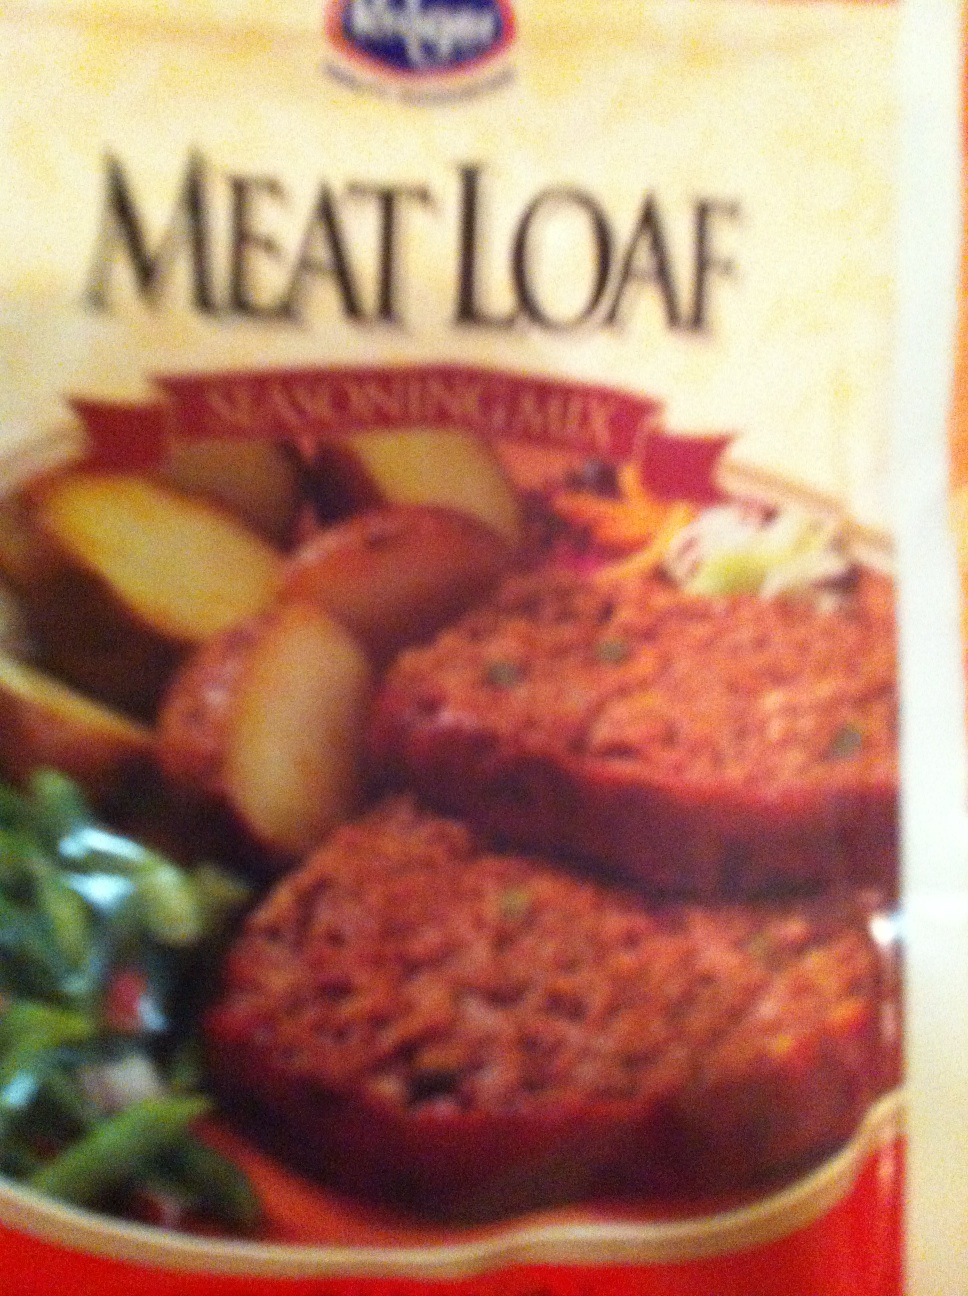Could you tell the contents of this package please? Thank you. Good Morning. Good morning! The package contains meatloaf. It appears to be a pre-made, ready-to-cook meatloaf that can be conveniently prepared at home. Enjoy your meal! 